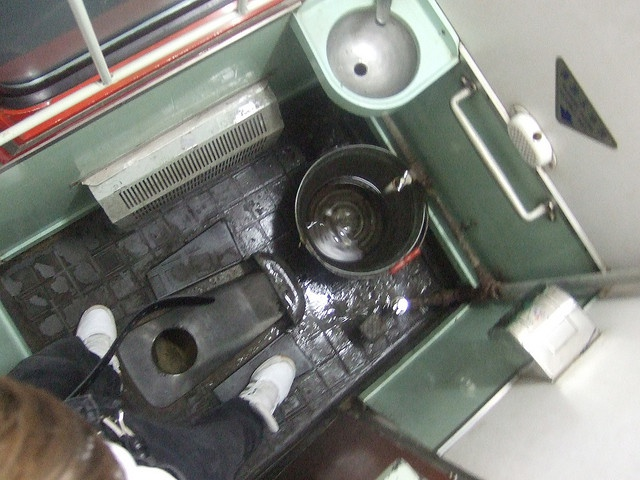Describe the objects in this image and their specific colors. I can see people in purple, black, gray, lightgray, and maroon tones, sink in purple, ivory, darkgray, and gray tones, and toilet in purple, gray, and black tones in this image. 